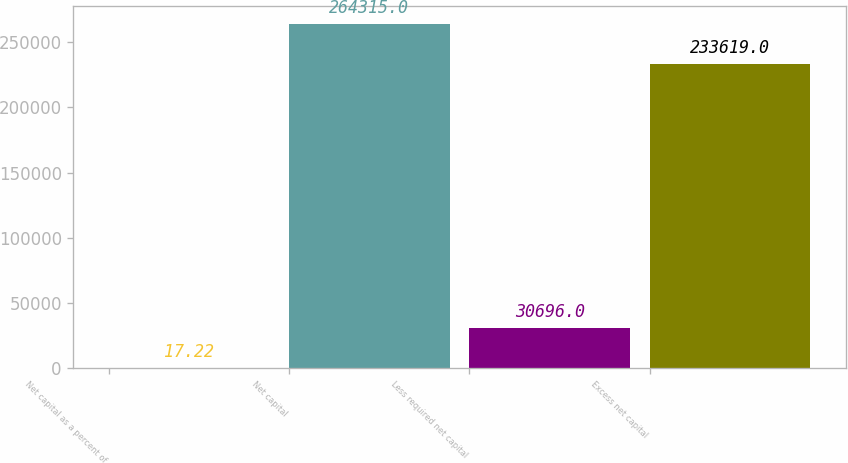Convert chart. <chart><loc_0><loc_0><loc_500><loc_500><bar_chart><fcel>Net capital as a percent of<fcel>Net capital<fcel>Less required net capital<fcel>Excess net capital<nl><fcel>17.22<fcel>264315<fcel>30696<fcel>233619<nl></chart> 